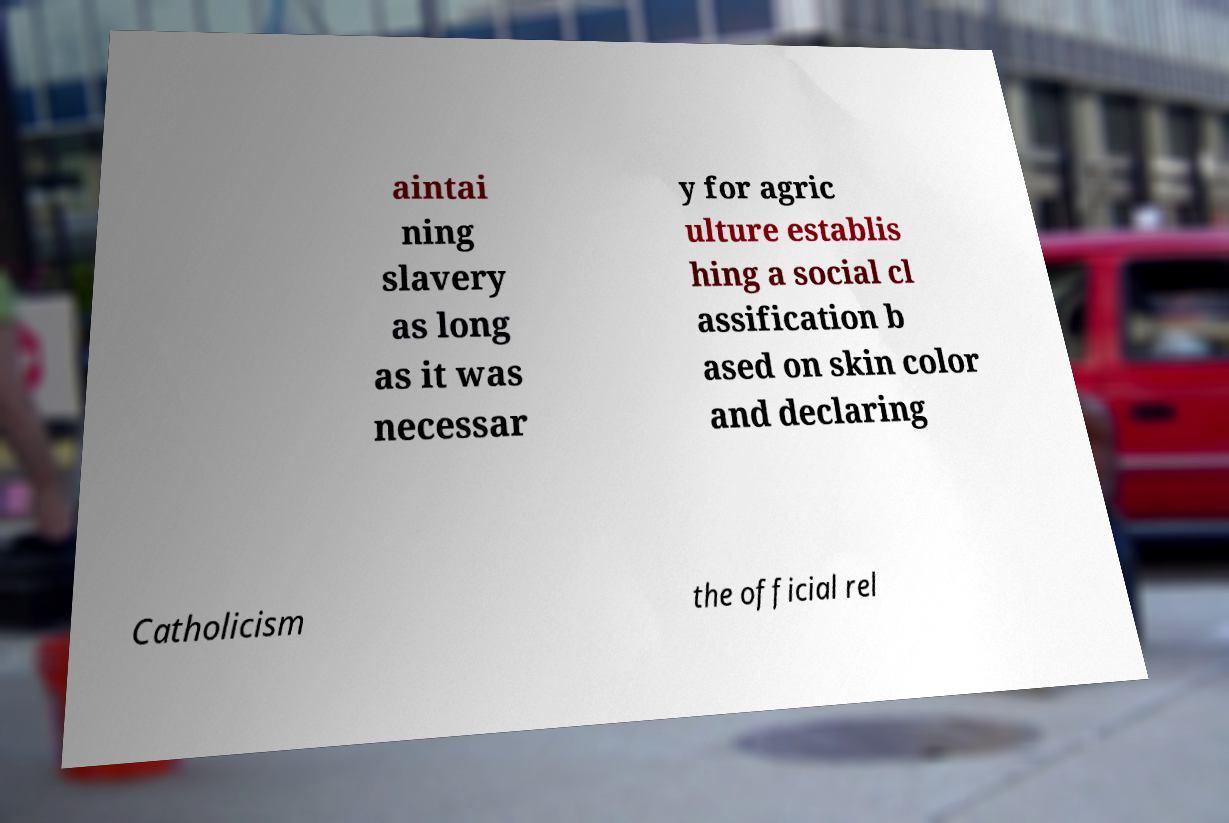There's text embedded in this image that I need extracted. Can you transcribe it verbatim? aintai ning slavery as long as it was necessar y for agric ulture establis hing a social cl assification b ased on skin color and declaring Catholicism the official rel 